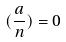<formula> <loc_0><loc_0><loc_500><loc_500>( \frac { a } { n } ) = 0</formula> 